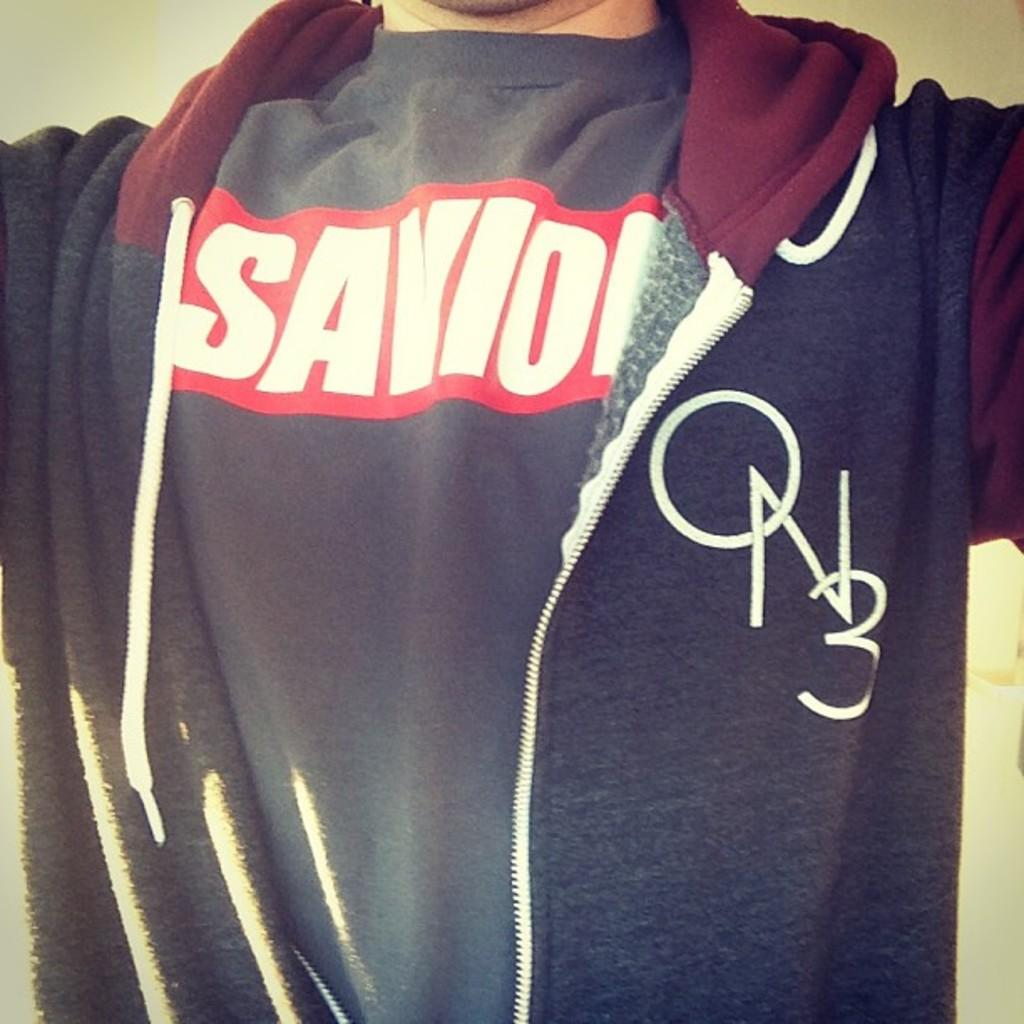What is the main subject of the image? There is a person in the image. What is the person wearing in the image? The person is wearing a jacket. How many children are playing with the bone in the image? There are no children or bones present in the image. What type of cookware is visible in the image? There is no cookware visible in the image; it only features a person wearing a jacket. 